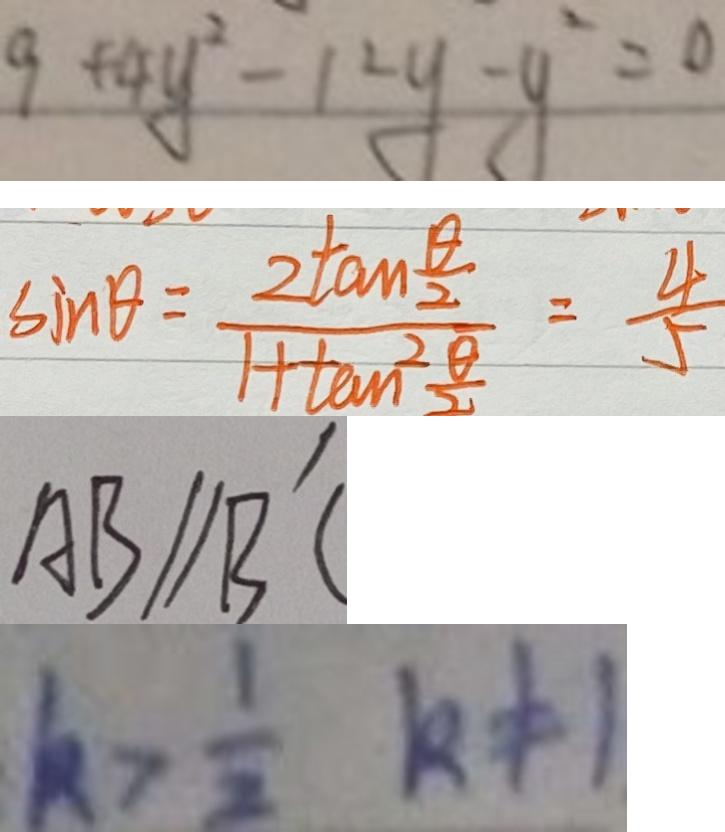<formula> <loc_0><loc_0><loc_500><loc_500>9 + 4 y ^ { 2 } - 1 2 y - y ^ { 2 } = 0 
 \sin \theta = \frac { 2 \tan \frac { \theta } { 2 } } { 1 + \tan ^ { 2 } \frac { \alpha } { 2 } } = \frac { 4 } { 5 } 
 A B / / B ^ { \prime } C 
 k > \frac { 1 } { 2 } k \neq 1</formula> 